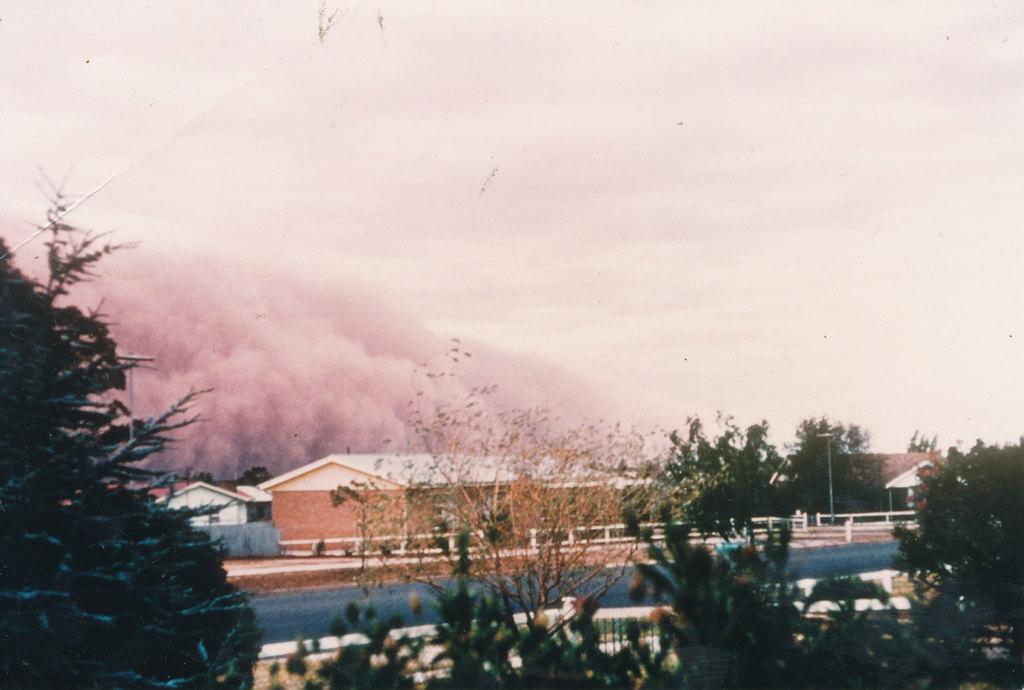In one or two sentences, can you explain what this image depicts? Here in this picture we can see houses present on the ground and we can also see a road with railings beside it and in the front we can see plants and trees present and we can see clouds covered all over the sky over there. 